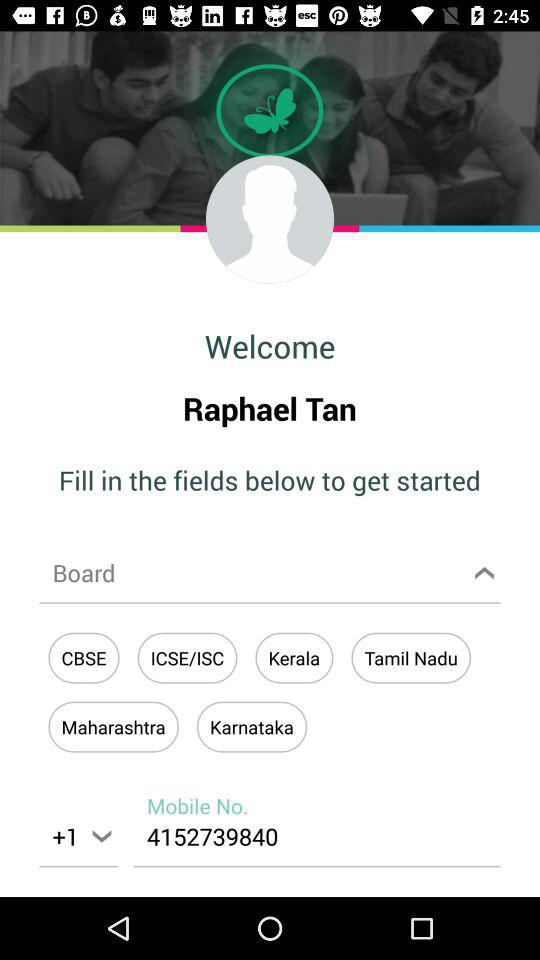How many digits are in the mobile number?
Answer the question using a single word or phrase. 10 